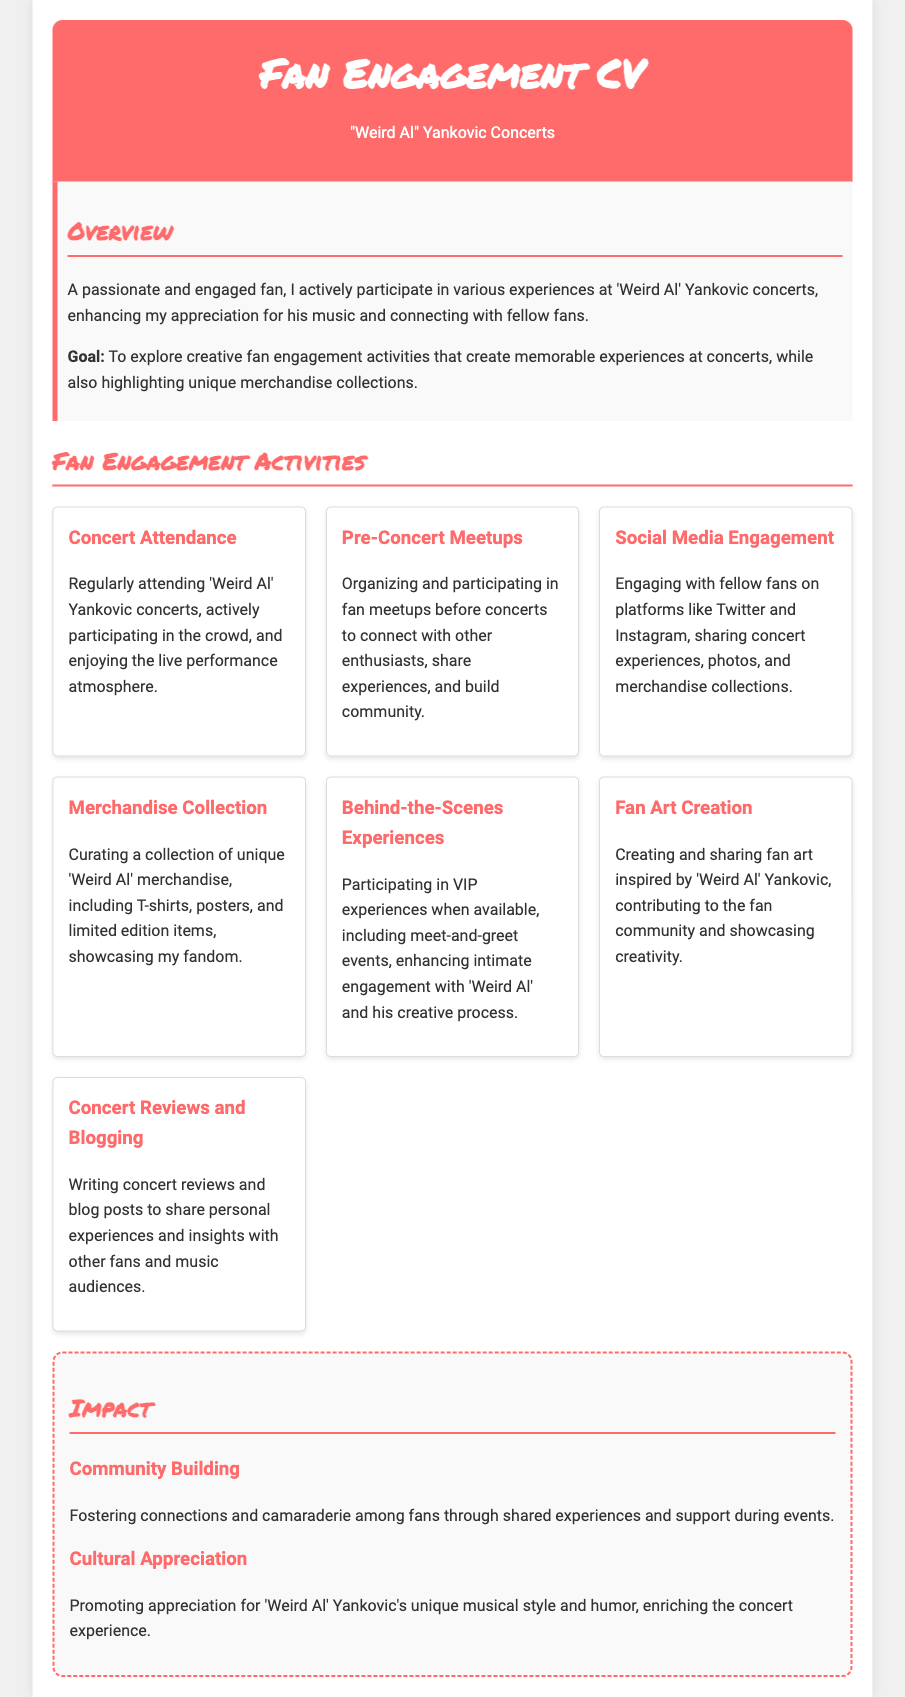What is a goal mentioned in the document? The goal is described as creating memorable experiences at concerts and highlighting unique merchandise collections.
Answer: Explore creative fan engagement activities How many activities are listed under Fan Engagement Activities? The document outlines various fan engagement activities; counting them gives the total.
Answer: Seven Which merchandise items are mentioned in the Merchandise Collection activity? The activity lists specific types of merchandise showcasing the fandom.
Answer: T-shirts, posters, and limited edition items What type of experiences does the Behind-the-Scenes Experiences activity include? The document specifies the kinds of intimate engagements available.
Answer: VIP experiences What is a focus of the Community Building section under Impact? The impact discusses the connections made among fans; determining the focus requires reviewing the text closely.
Answer: Connections and camaraderie When does social media engagement occur? The document mentions a specific context for social media interactions related to concerts and merchandise.
Answer: After concerts What kind of content is generated through Concert Reviews and Blogging? The activity suggests what type of writing is created based on the concert experience described.
Answer: Personal experiences and insights What theme does the Cultural Appreciation section promote? The impact mentions specific themes related to the artist’s musical style and humor.
Answer: Appreciation for 'Weird Al' Yankovic's unique musical style 